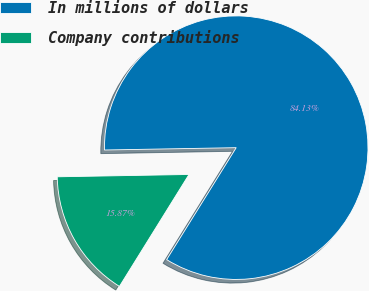Convert chart. <chart><loc_0><loc_0><loc_500><loc_500><pie_chart><fcel>In millions of dollars<fcel>Company contributions<nl><fcel>84.13%<fcel>15.87%<nl></chart> 